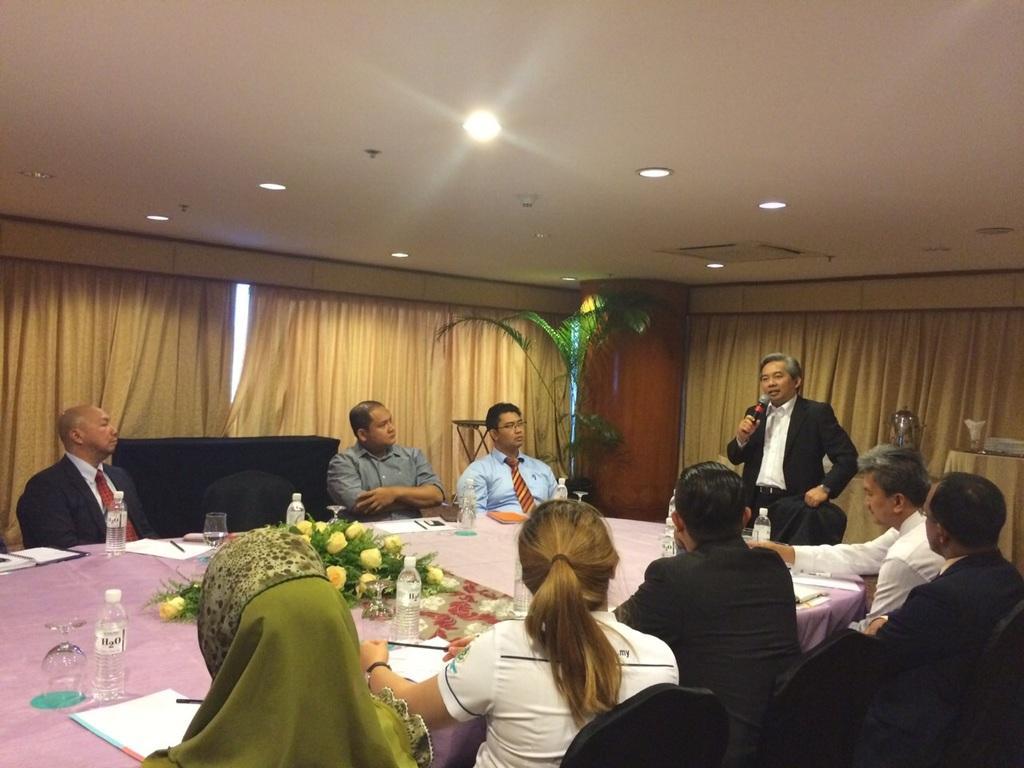Could you give a brief overview of what you see in this image? It seems to be the image is inside the conference hall. In the image there are group of people sitting on chair in front of a table, on table we can see a book,paper,pen,water bottle,wine glass and a plant with some flowers and cloth on table. On right side there is man standing and holding a microphone on his hand for talking, in background we can see pillar,plant,curtains,window on top there is a roof with few lights. 